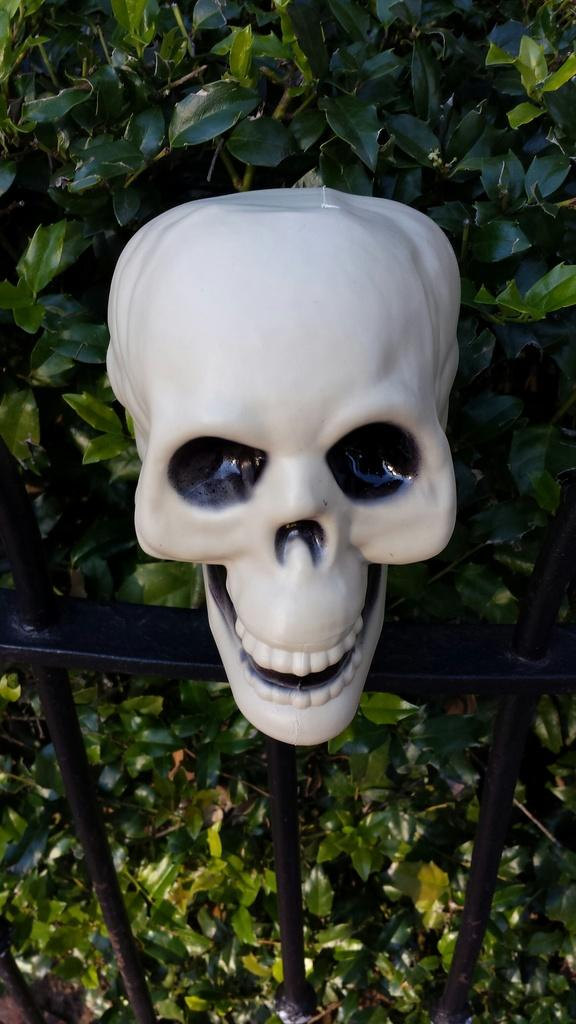What object is placed on the railing in the image? There is a skull on the railing in the image. What can be seen behind the railing in the image? There is a plant behind the railing in the image. What type of harbor is visible in the image? There is no harbor present in the image; it features a skull on a railing and a plant behind the railing. What is the order of the objects in the image? The order of the objects in the image cannot be determined without more specific information about their arrangement. 